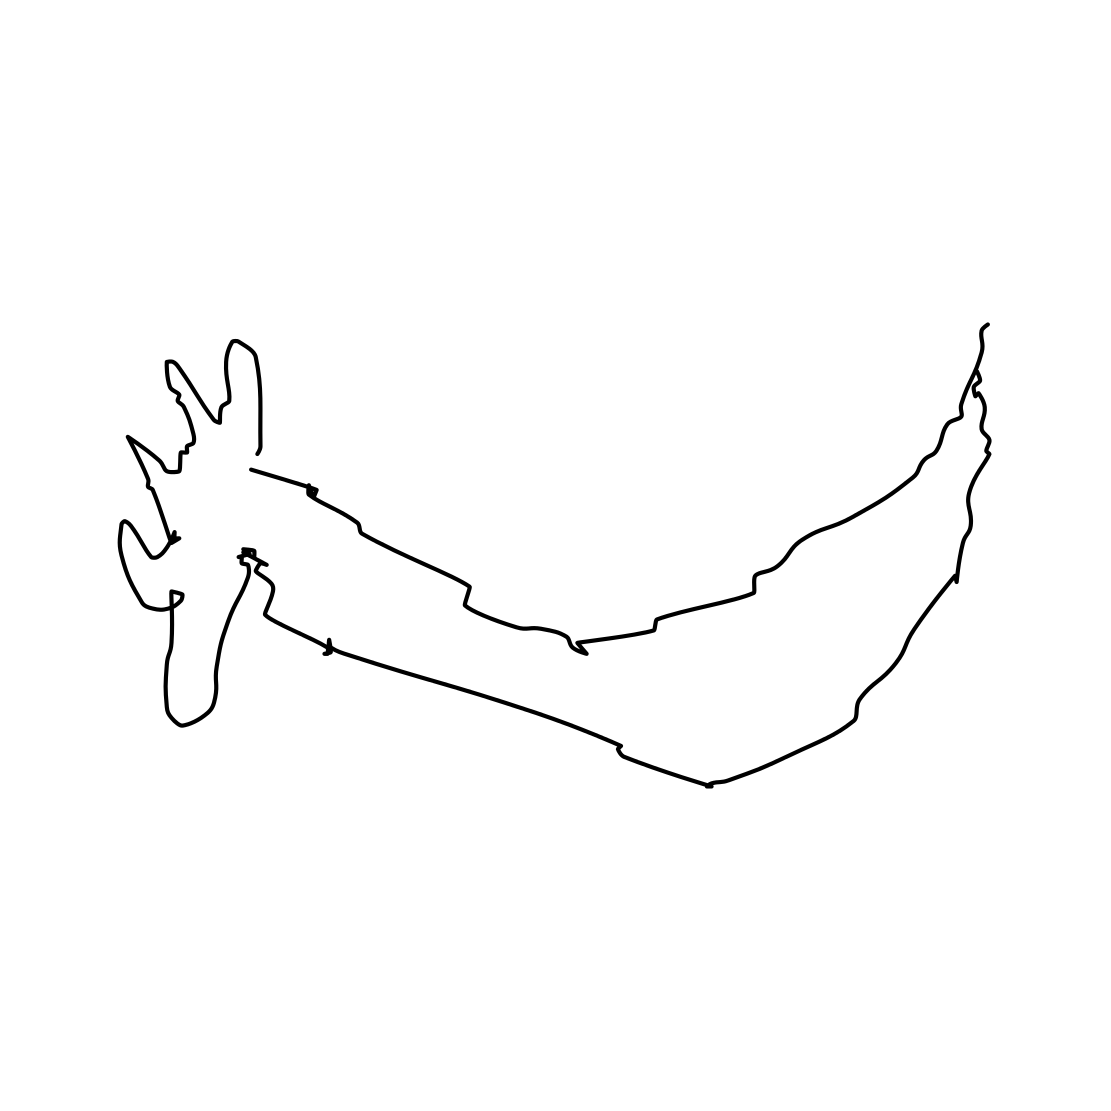How might this image be used in different contexts? This image could be used in various contexts such as a logo for a wildlife conservation organization, a minimalist poster for a nature-themed event, a graphic element in a mobile application about wild animals, or simply as an artistic decoration piece. Could this image be interpreted in any other way? Certainly. Art is open to interpretation, and while this image resembles a deer or reindeer, some might see it as an abstract composition or associate it with symbolic meanings, such as wilderness, freedom, or the Christmas holiday season. 